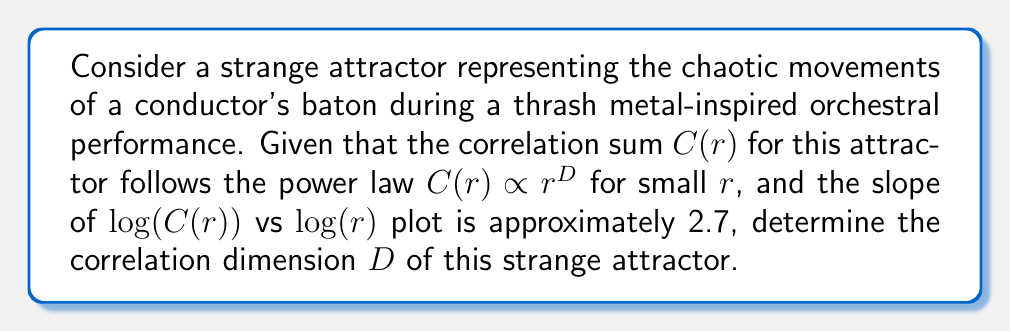Can you answer this question? To determine the correlation dimension of the strange attractor, we'll follow these steps:

1) The correlation dimension $D$ is defined by the power law relationship:

   $$C(r) \propto r^D$$

   where $C(r)$ is the correlation sum and $r$ is the radius.

2) Taking the logarithm of both sides:

   $$\log(C(r)) \propto D \log(r)$$

3) This equation represents a linear relationship between $\log(C(r))$ and $\log(r)$, where $D$ is the slope of the line.

4) We're given that the slope of the $\log(C(r))$ vs $\log(r)$ plot is approximately 2.7.

5) Therefore, the correlation dimension $D$ is equal to this slope:

   $$D \approx 2.7$$

6) This non-integer dimension (between 2 and 3) is characteristic of strange attractors, indicating the fractal nature of the baton's chaotic movements.
Answer: $D \approx 2.7$ 